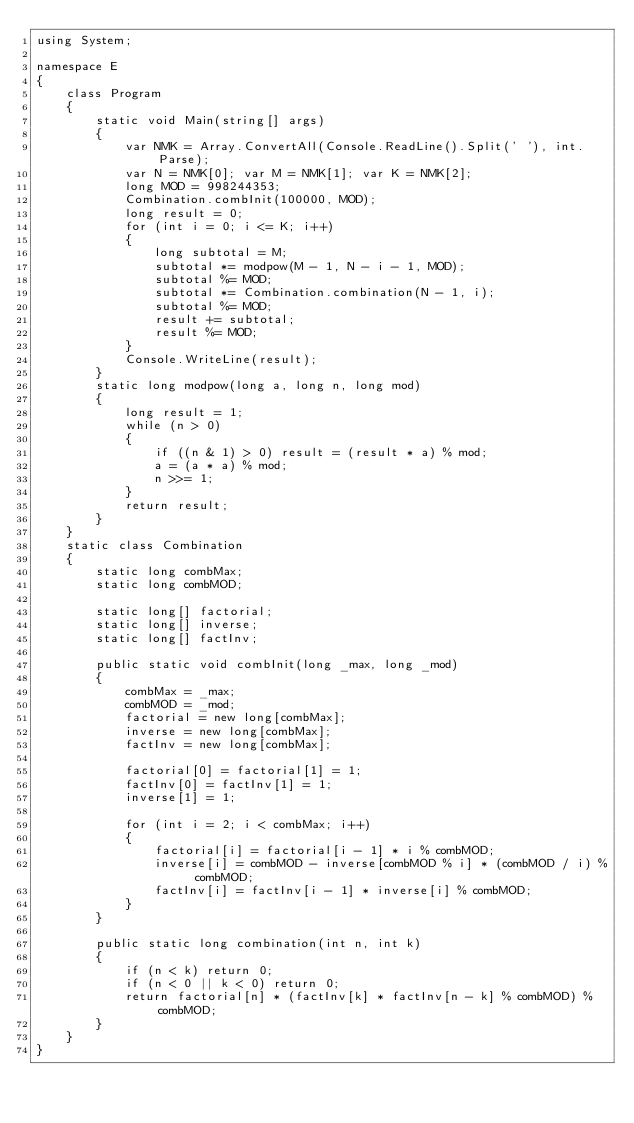Convert code to text. <code><loc_0><loc_0><loc_500><loc_500><_C#_>using System;

namespace E
{
    class Program
    {
        static void Main(string[] args)
        {
            var NMK = Array.ConvertAll(Console.ReadLine().Split(' '), int.Parse);
            var N = NMK[0]; var M = NMK[1]; var K = NMK[2];
            long MOD = 998244353;
            Combination.combInit(100000, MOD);
            long result = 0;
            for (int i = 0; i <= K; i++)
            {
                long subtotal = M;
                subtotal *= modpow(M - 1, N - i - 1, MOD);
                subtotal %= MOD;
                subtotal *= Combination.combination(N - 1, i);
                subtotal %= MOD;
                result += subtotal;
                result %= MOD;
            }
            Console.WriteLine(result);
        }
        static long modpow(long a, long n, long mod)
        {
            long result = 1;
            while (n > 0)
            {
                if ((n & 1) > 0) result = (result * a) % mod;
                a = (a * a) % mod;
                n >>= 1;
            }
            return result;
        }
    }
    static class Combination
    {
        static long combMax;
        static long combMOD;

        static long[] factorial;
        static long[] inverse;
        static long[] factInv;

        public static void combInit(long _max, long _mod)
        {
            combMax = _max;
            combMOD = _mod;
            factorial = new long[combMax];
            inverse = new long[combMax];
            factInv = new long[combMax];

            factorial[0] = factorial[1] = 1;
            factInv[0] = factInv[1] = 1;
            inverse[1] = 1;

            for (int i = 2; i < combMax; i++)
            {
                factorial[i] = factorial[i - 1] * i % combMOD;
                inverse[i] = combMOD - inverse[combMOD % i] * (combMOD / i) % combMOD;
                factInv[i] = factInv[i - 1] * inverse[i] % combMOD;
            }
        }

        public static long combination(int n, int k)
        {
            if (n < k) return 0;
            if (n < 0 || k < 0) return 0;
            return factorial[n] * (factInv[k] * factInv[n - k] % combMOD) % combMOD;
        }
    }
}
</code> 